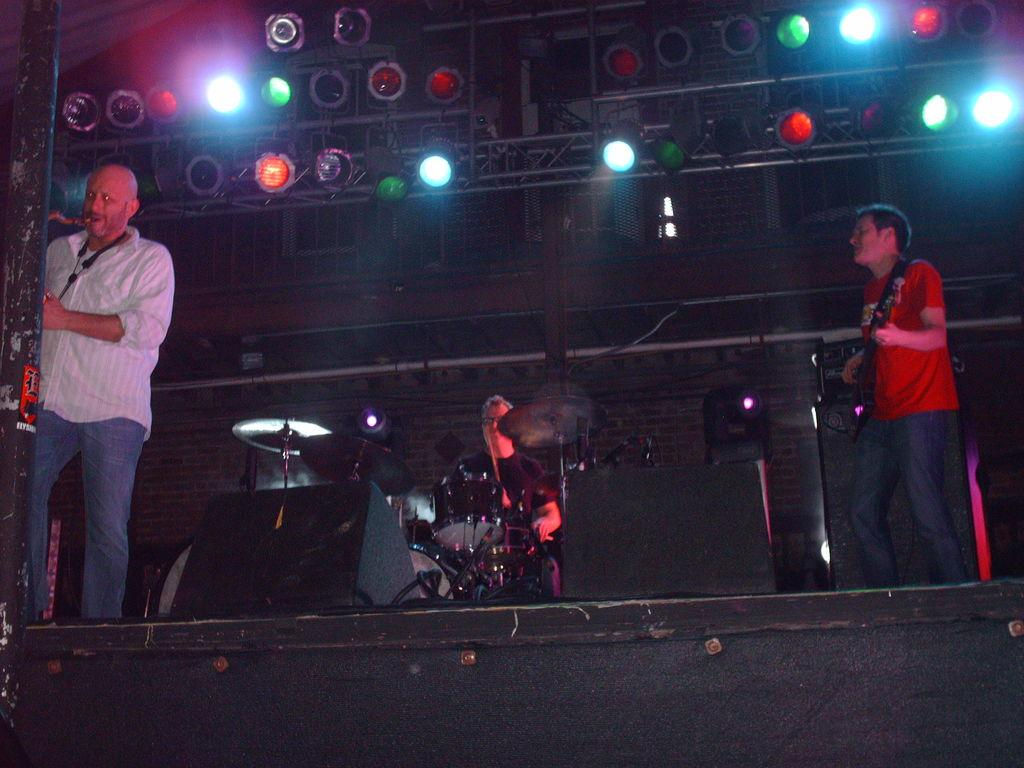What are the people in the image doing? The people in the image are playing musical instruments. Where are the people playing their instruments? The people are on a stage. What can be seen on the roof in the image? There are lights flashing from the roof in the image. What type of hammer is being used by the person playing the drums in the image? There is no hammer present in the image, and the person playing the drums is using drumsticks. Can you see any squirrels on the stage in the image? There are no squirrels present in the image; it features people playing musical instruments on a stage. 